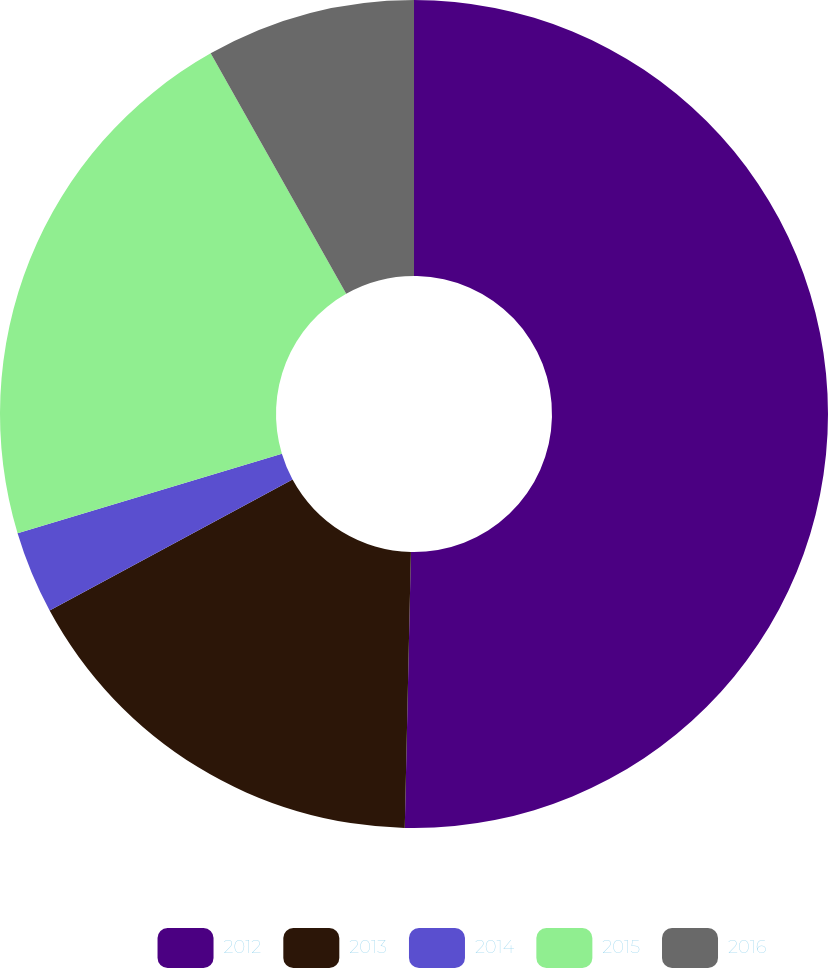Convert chart. <chart><loc_0><loc_0><loc_500><loc_500><pie_chart><fcel>2012<fcel>2013<fcel>2014<fcel>2015<fcel>2016<nl><fcel>50.35%<fcel>16.77%<fcel>3.22%<fcel>21.48%<fcel>8.17%<nl></chart> 